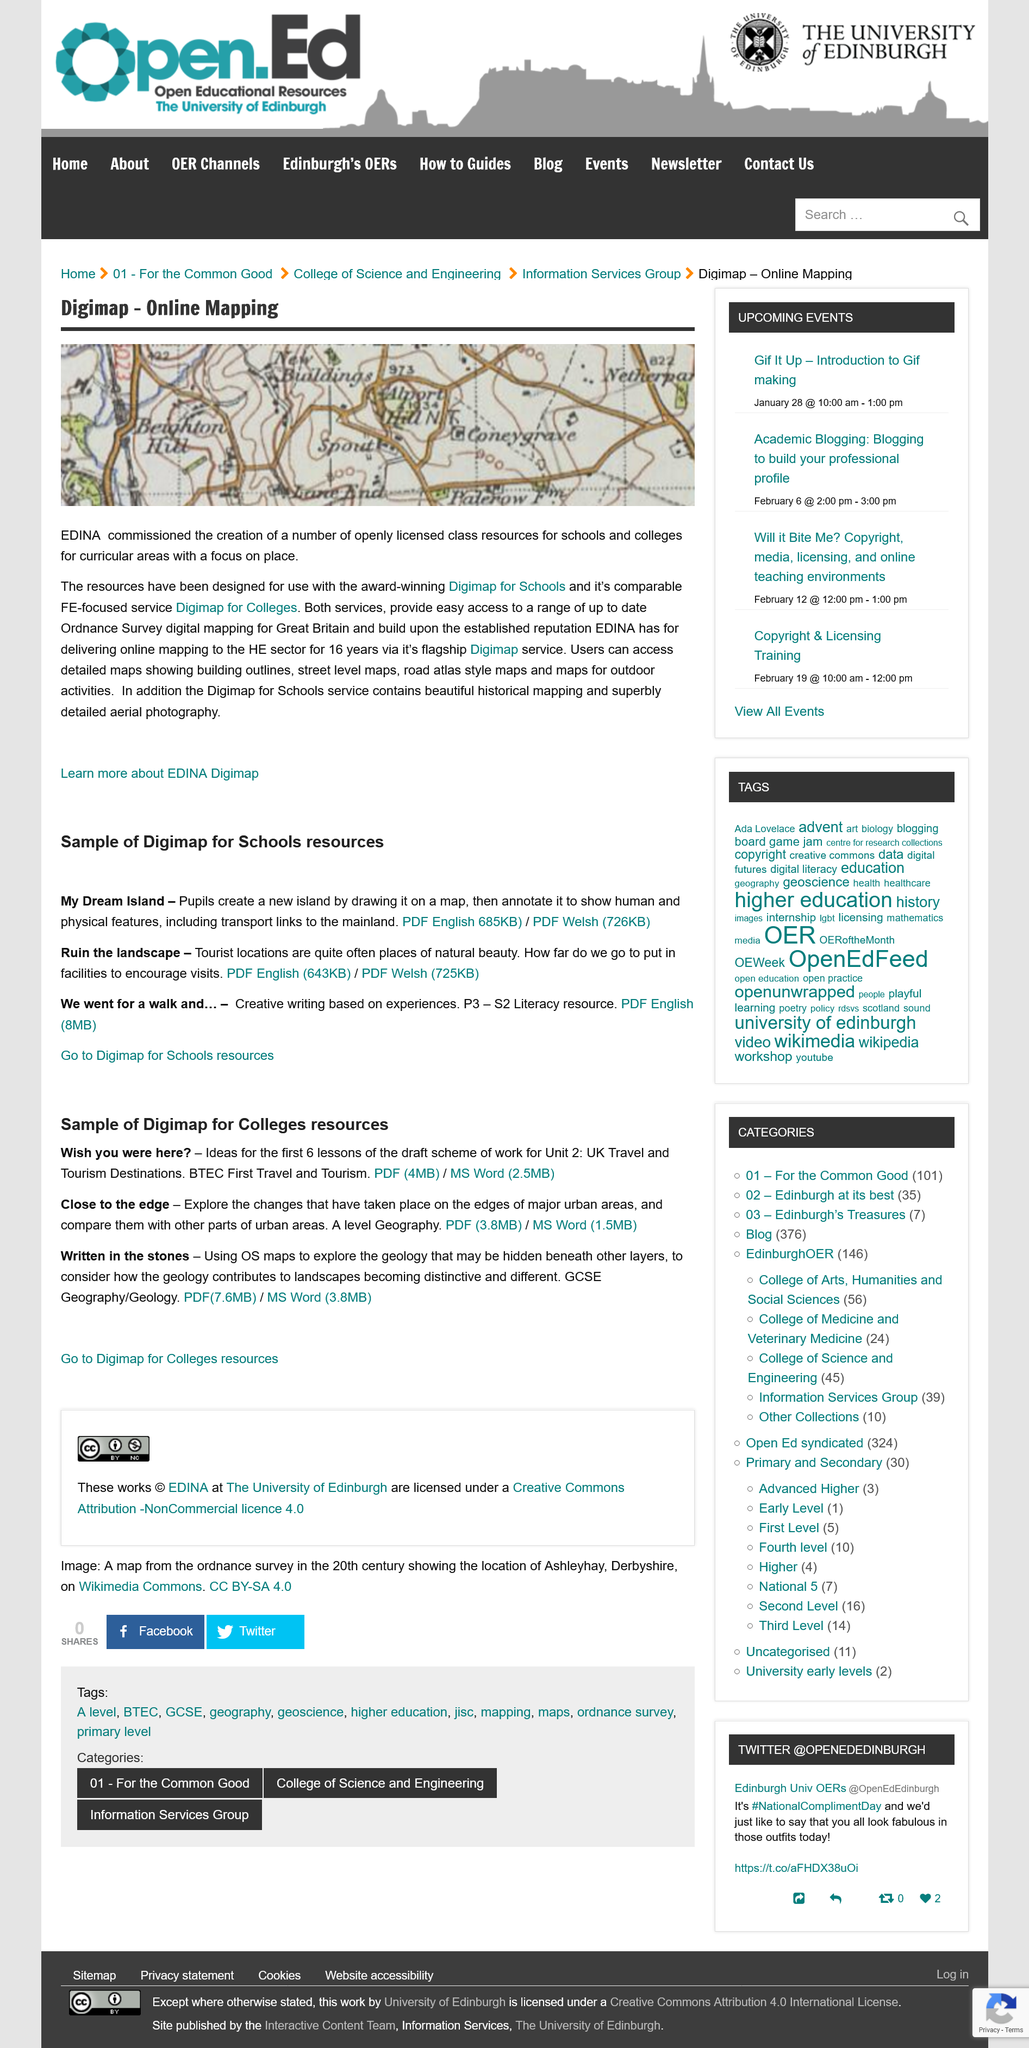Specify some key components in this picture. I would like to declare that three digimaps, "Wish you were here," "Close to the edge," and "Written in the stones," are suitable resources for colleges. I hereby declare that "Name three digimaps for Schools?" is a grammatically correct sentence. The sentence is a declaration of preference, stating the speaker's dream landscapes for digital maps in schools. The image depicts two hills, Beighton Hill and Alport Hill, both of which can be seen on the map. In participating in the Close to the edge digimap, college pupils explore the changes that have occurred on the edge of major urban areas and compare them with other urban areas. For 16 years, Digimap has been delivering maps to the higher education sector. 